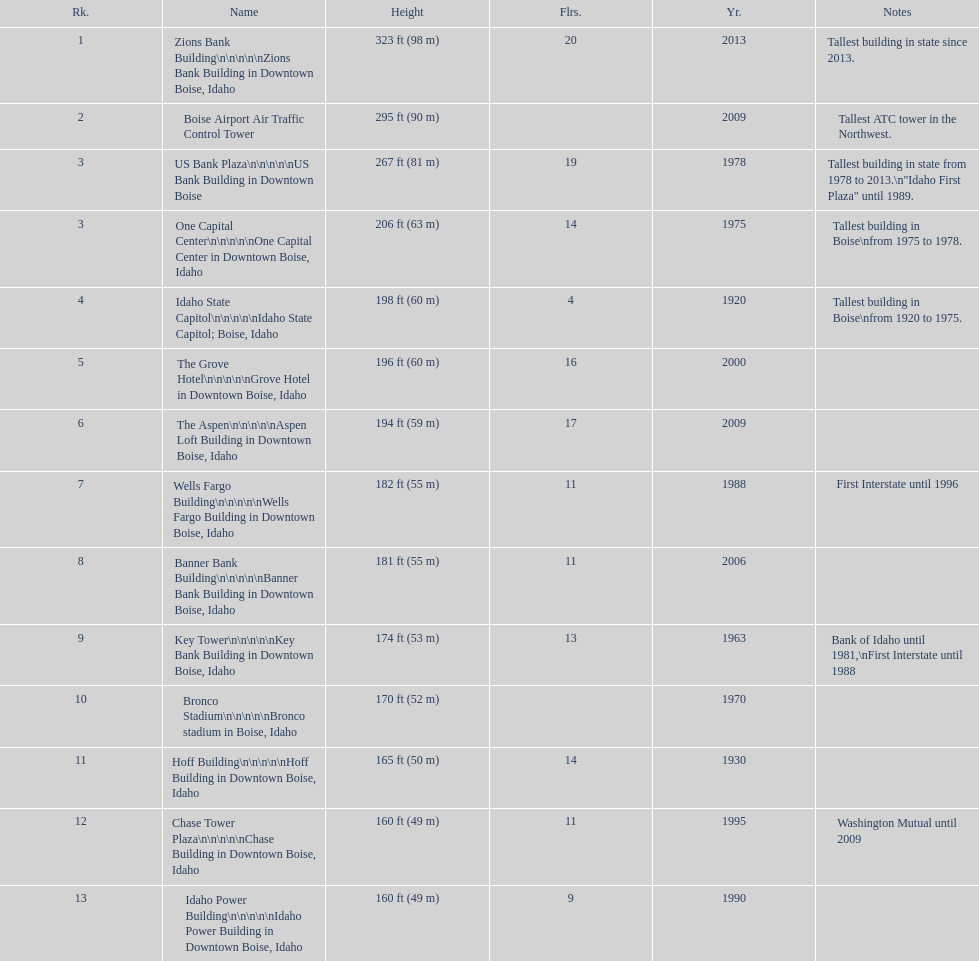How many buildings have at least ten floors? 10. Can you give me this table as a dict? {'header': ['Rk.', 'Name', 'Height', 'Flrs.', 'Yr.', 'Notes'], 'rows': [['1', 'Zions Bank Building\\n\\n\\n\\n\\nZions Bank Building in Downtown Boise, Idaho', '323\xa0ft (98\xa0m)', '20', '2013', 'Tallest building in state since 2013.'], ['2', 'Boise Airport Air Traffic Control Tower', '295\xa0ft (90\xa0m)', '', '2009', 'Tallest ATC tower in the Northwest.'], ['3', 'US Bank Plaza\\n\\n\\n\\n\\nUS Bank Building in Downtown Boise', '267\xa0ft (81\xa0m)', '19', '1978', 'Tallest building in state from 1978 to 2013.\\n"Idaho First Plaza" until 1989.'], ['3', 'One Capital Center\\n\\n\\n\\n\\nOne Capital Center in Downtown Boise, Idaho', '206\xa0ft (63\xa0m)', '14', '1975', 'Tallest building in Boise\\nfrom 1975 to 1978.'], ['4', 'Idaho State Capitol\\n\\n\\n\\n\\nIdaho State Capitol; Boise, Idaho', '198\xa0ft (60\xa0m)', '4', '1920', 'Tallest building in Boise\\nfrom 1920 to 1975.'], ['5', 'The Grove Hotel\\n\\n\\n\\n\\nGrove Hotel in Downtown Boise, Idaho', '196\xa0ft (60\xa0m)', '16', '2000', ''], ['6', 'The Aspen\\n\\n\\n\\n\\nAspen Loft Building in Downtown Boise, Idaho', '194\xa0ft (59\xa0m)', '17', '2009', ''], ['7', 'Wells Fargo Building\\n\\n\\n\\n\\nWells Fargo Building in Downtown Boise, Idaho', '182\xa0ft (55\xa0m)', '11', '1988', 'First Interstate until 1996'], ['8', 'Banner Bank Building\\n\\n\\n\\n\\nBanner Bank Building in Downtown Boise, Idaho', '181\xa0ft (55\xa0m)', '11', '2006', ''], ['9', 'Key Tower\\n\\n\\n\\n\\nKey Bank Building in Downtown Boise, Idaho', '174\xa0ft (53\xa0m)', '13', '1963', 'Bank of Idaho until 1981,\\nFirst Interstate until 1988'], ['10', 'Bronco Stadium\\n\\n\\n\\n\\nBronco stadium in Boise, Idaho', '170\xa0ft (52\xa0m)', '', '1970', ''], ['11', 'Hoff Building\\n\\n\\n\\n\\nHoff Building in Downtown Boise, Idaho', '165\xa0ft (50\xa0m)', '14', '1930', ''], ['12', 'Chase Tower Plaza\\n\\n\\n\\n\\nChase Building in Downtown Boise, Idaho', '160\xa0ft (49\xa0m)', '11', '1995', 'Washington Mutual until 2009'], ['13', 'Idaho Power Building\\n\\n\\n\\n\\nIdaho Power Building in Downtown Boise, Idaho', '160\xa0ft (49\xa0m)', '9', '1990', '']]} 